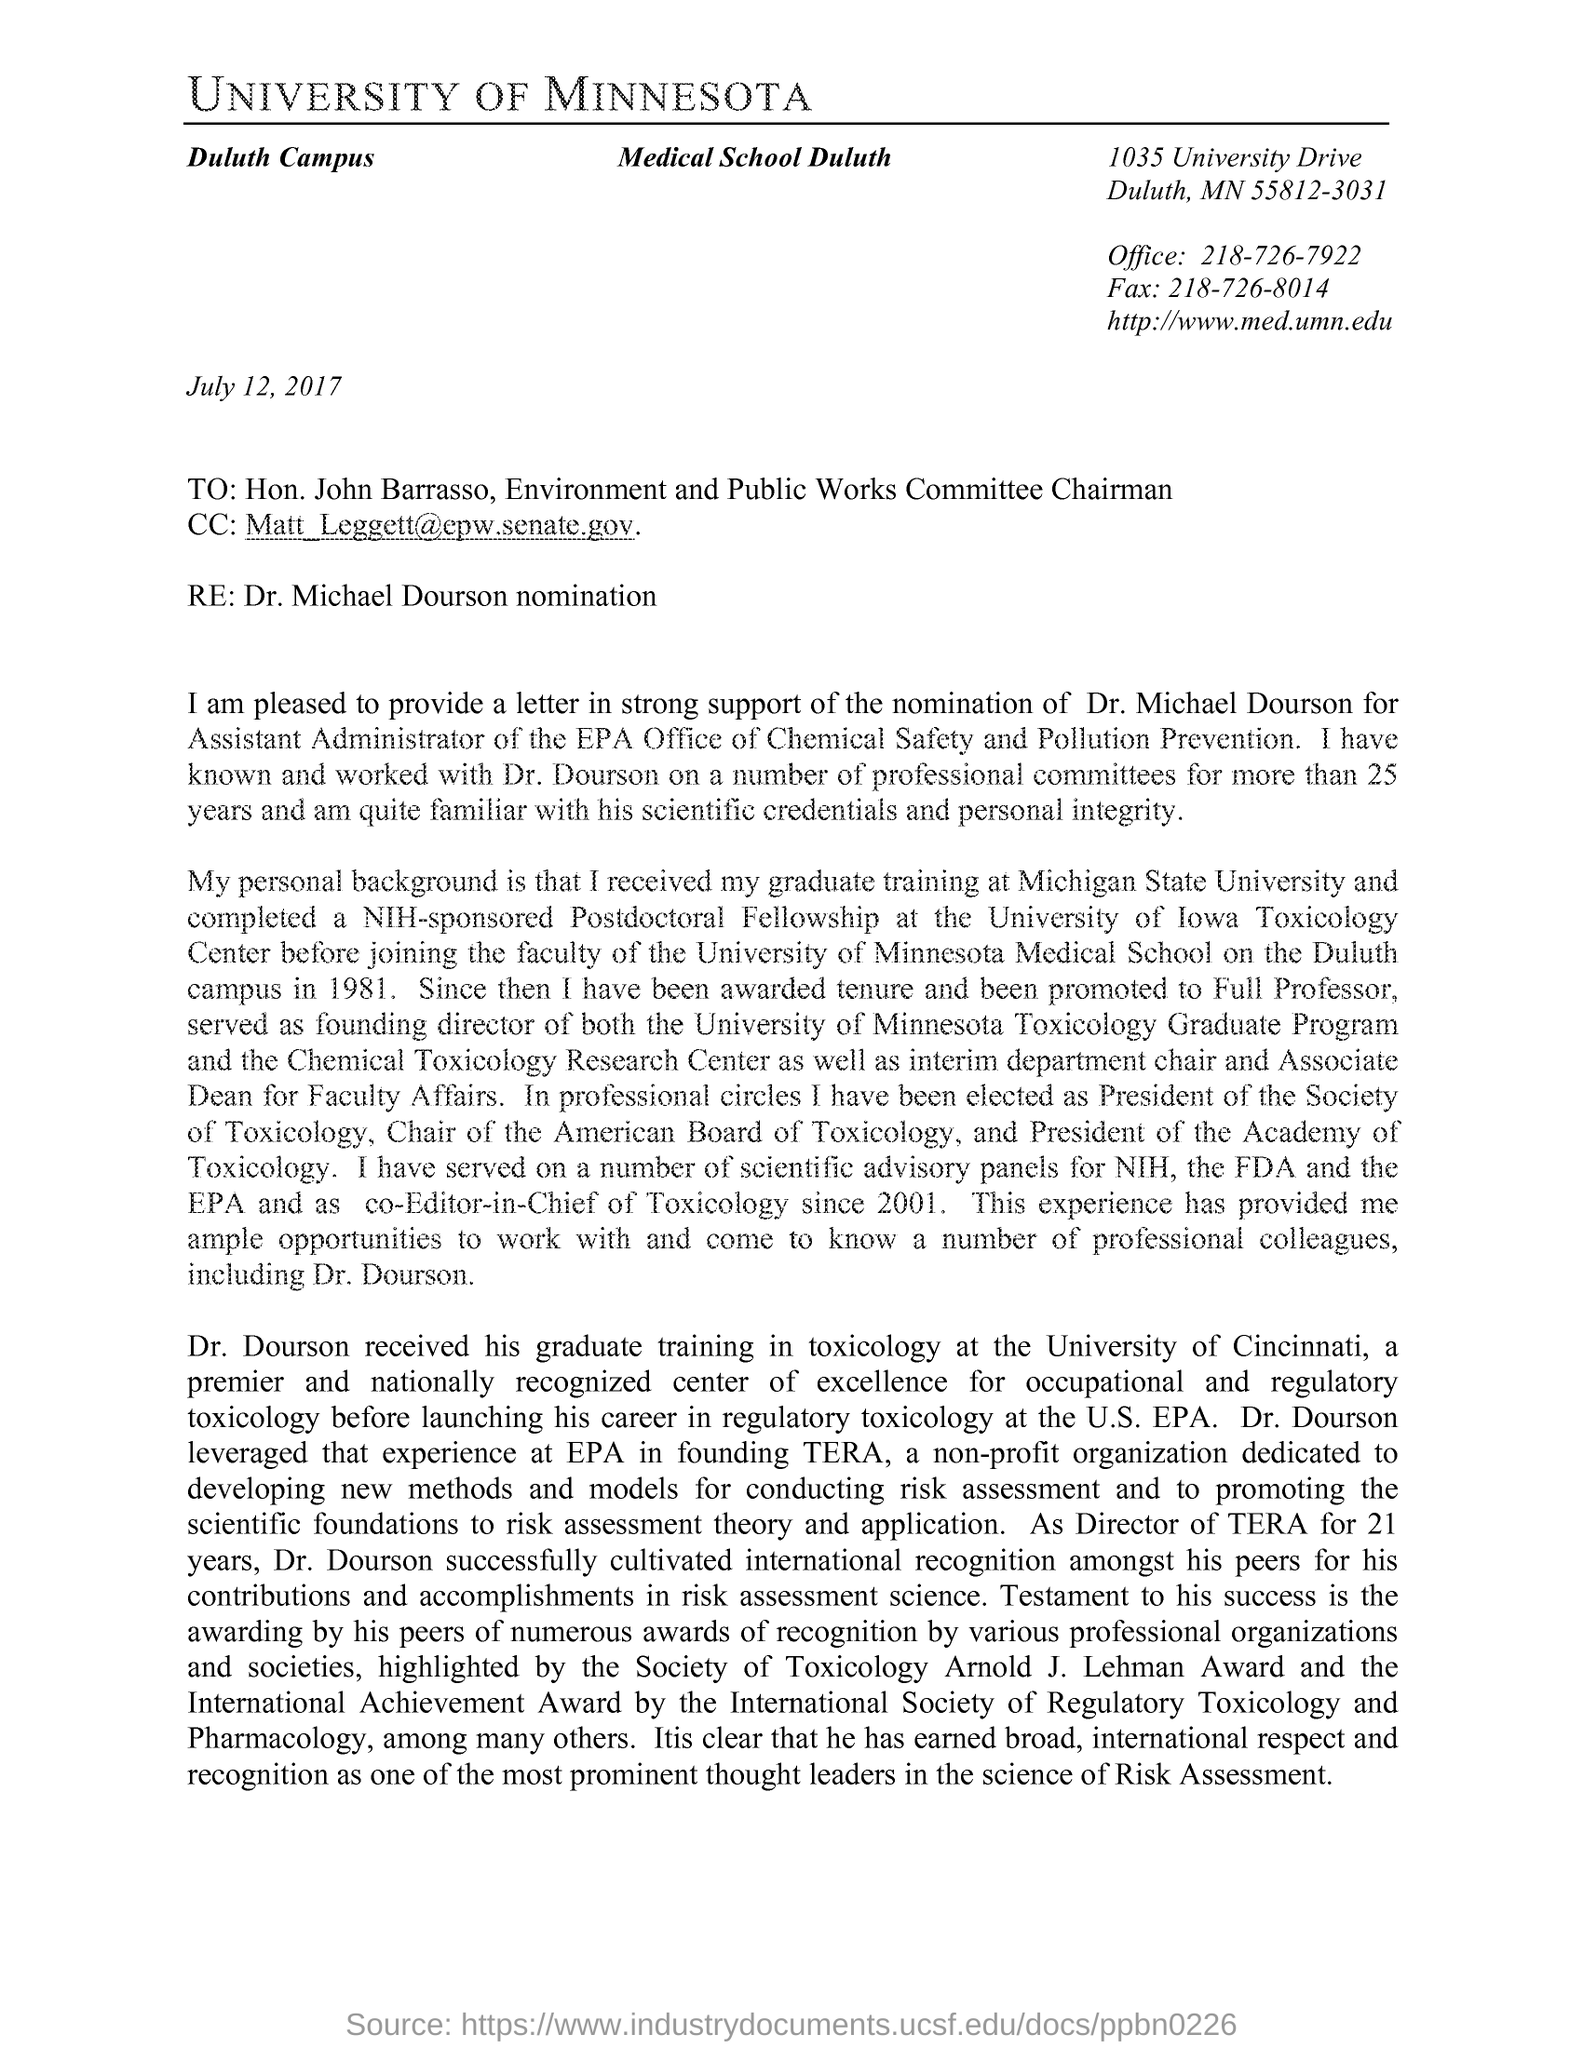What is the date mentioned in the document?
Keep it short and to the point. July 12, 2017. Who is the chairman of Environment and Public Works Committee?
Your answer should be compact. Hon. John Barrasso. What is the office number?
Keep it short and to the point. 218-726-7922. What is the Fax number?
Your answer should be compact. 218-726-8014. 